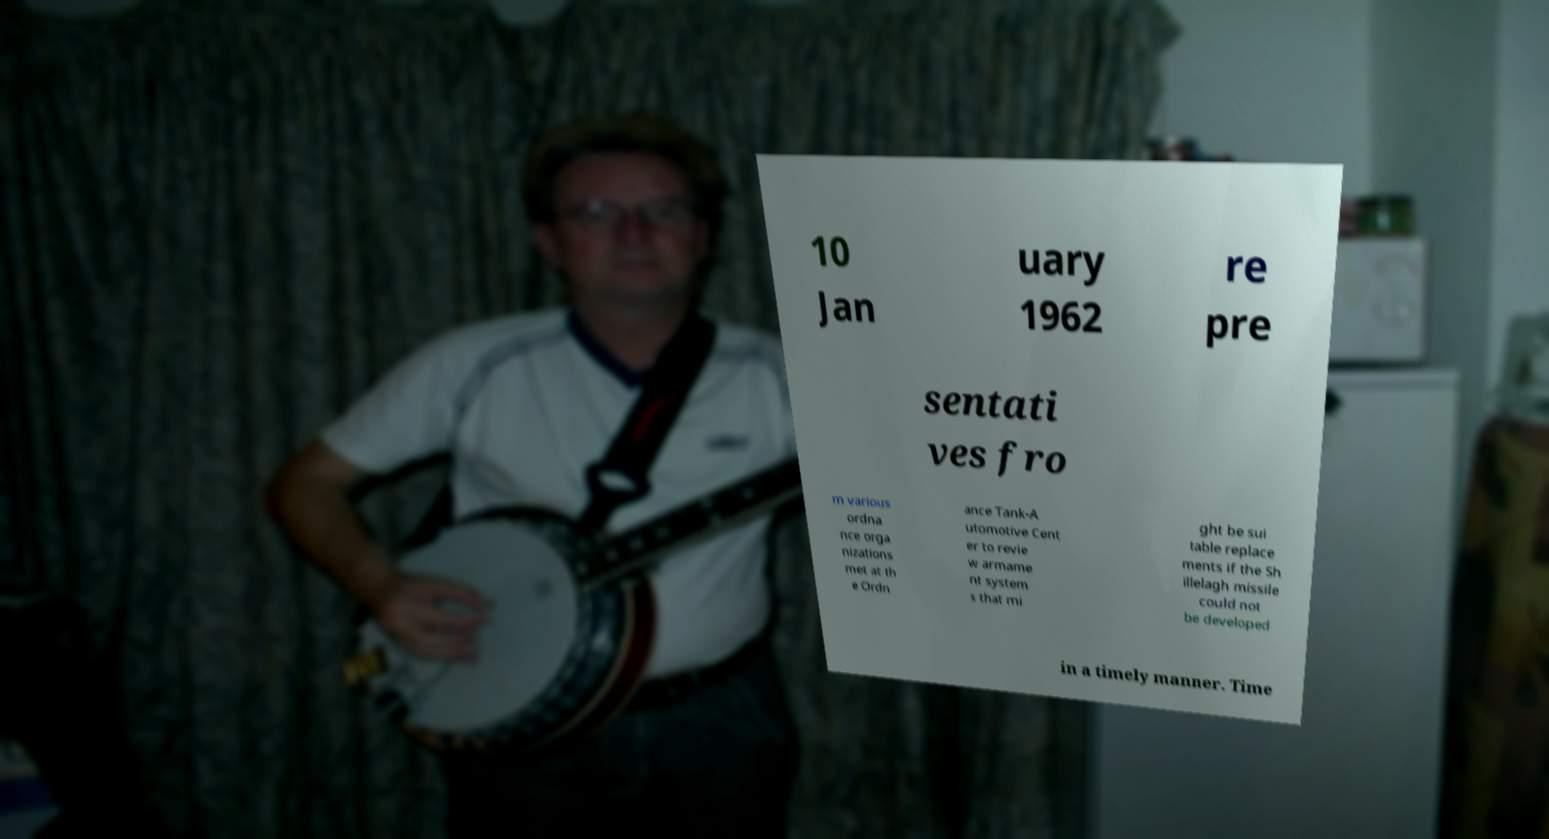I need the written content from this picture converted into text. Can you do that? 10 Jan uary 1962 re pre sentati ves fro m various ordna nce orga nizations met at th e Ordn ance Tank-A utomotive Cent er to revie w armame nt system s that mi ght be sui table replace ments if the Sh illelagh missile could not be developed in a timely manner. Time 